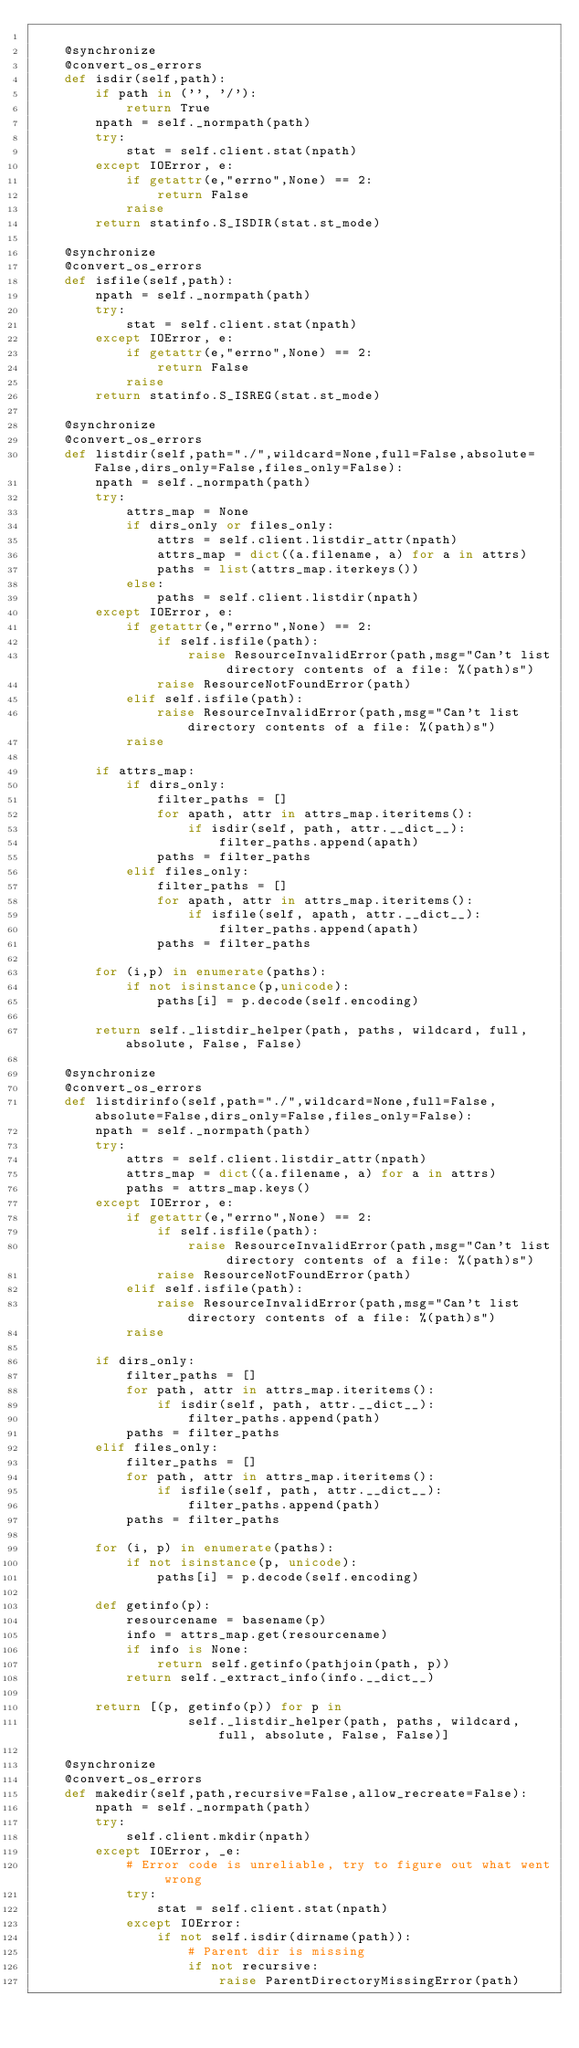Convert code to text. <code><loc_0><loc_0><loc_500><loc_500><_Python_>
    @synchronize
    @convert_os_errors
    def isdir(self,path):
        if path in ('', '/'):
            return True
        npath = self._normpath(path)
        try:
            stat = self.client.stat(npath)
        except IOError, e:
            if getattr(e,"errno",None) == 2:
                return False
            raise
        return statinfo.S_ISDIR(stat.st_mode)

    @synchronize
    @convert_os_errors
    def isfile(self,path):
        npath = self._normpath(path)
        try:
            stat = self.client.stat(npath)
        except IOError, e:
            if getattr(e,"errno",None) == 2:
                return False
            raise
        return statinfo.S_ISREG(stat.st_mode)

    @synchronize
    @convert_os_errors
    def listdir(self,path="./",wildcard=None,full=False,absolute=False,dirs_only=False,files_only=False):
        npath = self._normpath(path)
        try:            
            attrs_map = None
            if dirs_only or files_only:                
                attrs = self.client.listdir_attr(npath)
                attrs_map = dict((a.filename, a) for a in attrs)
                paths = list(attrs_map.iterkeys())                                            
            else:
                paths = self.client.listdir(npath)                                            
        except IOError, e:
            if getattr(e,"errno",None) == 2:
                if self.isfile(path):
                    raise ResourceInvalidError(path,msg="Can't list directory contents of a file: %(path)s")
                raise ResourceNotFoundError(path)
            elif self.isfile(path):
                raise ResourceInvalidError(path,msg="Can't list directory contents of a file: %(path)s")
            raise                        
                
        if attrs_map:
            if dirs_only:
                filter_paths = []
                for apath, attr in attrs_map.iteritems():
                    if isdir(self, path, attr.__dict__):
                        filter_paths.append(apath)
                paths = filter_paths
            elif files_only:
                filter_paths = []
                for apath, attr in attrs_map.iteritems():
                    if isfile(self, apath, attr.__dict__):
                        filter_paths.append(apath)
                paths = filter_paths                
        
        for (i,p) in enumerate(paths):
            if not isinstance(p,unicode):
                paths[i] = p.decode(self.encoding)                        
                
        return self._listdir_helper(path, paths, wildcard, full, absolute, False, False)

    @synchronize
    @convert_os_errors
    def listdirinfo(self,path="./",wildcard=None,full=False,absolute=False,dirs_only=False,files_only=False):
        npath = self._normpath(path)
        try:            
            attrs = self.client.listdir_attr(npath)
            attrs_map = dict((a.filename, a) for a in attrs)                        
            paths = attrs_map.keys()            
        except IOError, e:
            if getattr(e,"errno",None) == 2:
                if self.isfile(path):
                    raise ResourceInvalidError(path,msg="Can't list directory contents of a file: %(path)s")
                raise ResourceNotFoundError(path)
            elif self.isfile(path):
                raise ResourceInvalidError(path,msg="Can't list directory contents of a file: %(path)s")
            raise
            
        if dirs_only:
            filter_paths = []
            for path, attr in attrs_map.iteritems():
                if isdir(self, path, attr.__dict__):
                    filter_paths.append(path)
            paths = filter_paths
        elif files_only:
            filter_paths = []
            for path, attr in attrs_map.iteritems():
                if isfile(self, path, attr.__dict__):
                    filter_paths.append(path)
            paths = filter_paths
            
        for (i, p) in enumerate(paths):
            if not isinstance(p, unicode):
                paths[i] = p.decode(self.encoding)
                
        def getinfo(p):
            resourcename = basename(p)
            info = attrs_map.get(resourcename)
            if info is None:
                return self.getinfo(pathjoin(path, p))
            return self._extract_info(info.__dict__)
                
        return [(p, getinfo(p)) for p in 
                    self._listdir_helper(path, paths, wildcard, full, absolute, False, False)]

    @synchronize
    @convert_os_errors
    def makedir(self,path,recursive=False,allow_recreate=False):
        npath = self._normpath(path)
        try:
            self.client.mkdir(npath)
        except IOError, _e:
            # Error code is unreliable, try to figure out what went wrong
            try:
                stat = self.client.stat(npath)
            except IOError:
                if not self.isdir(dirname(path)):
                    # Parent dir is missing
                    if not recursive:
                        raise ParentDirectoryMissingError(path)</code> 